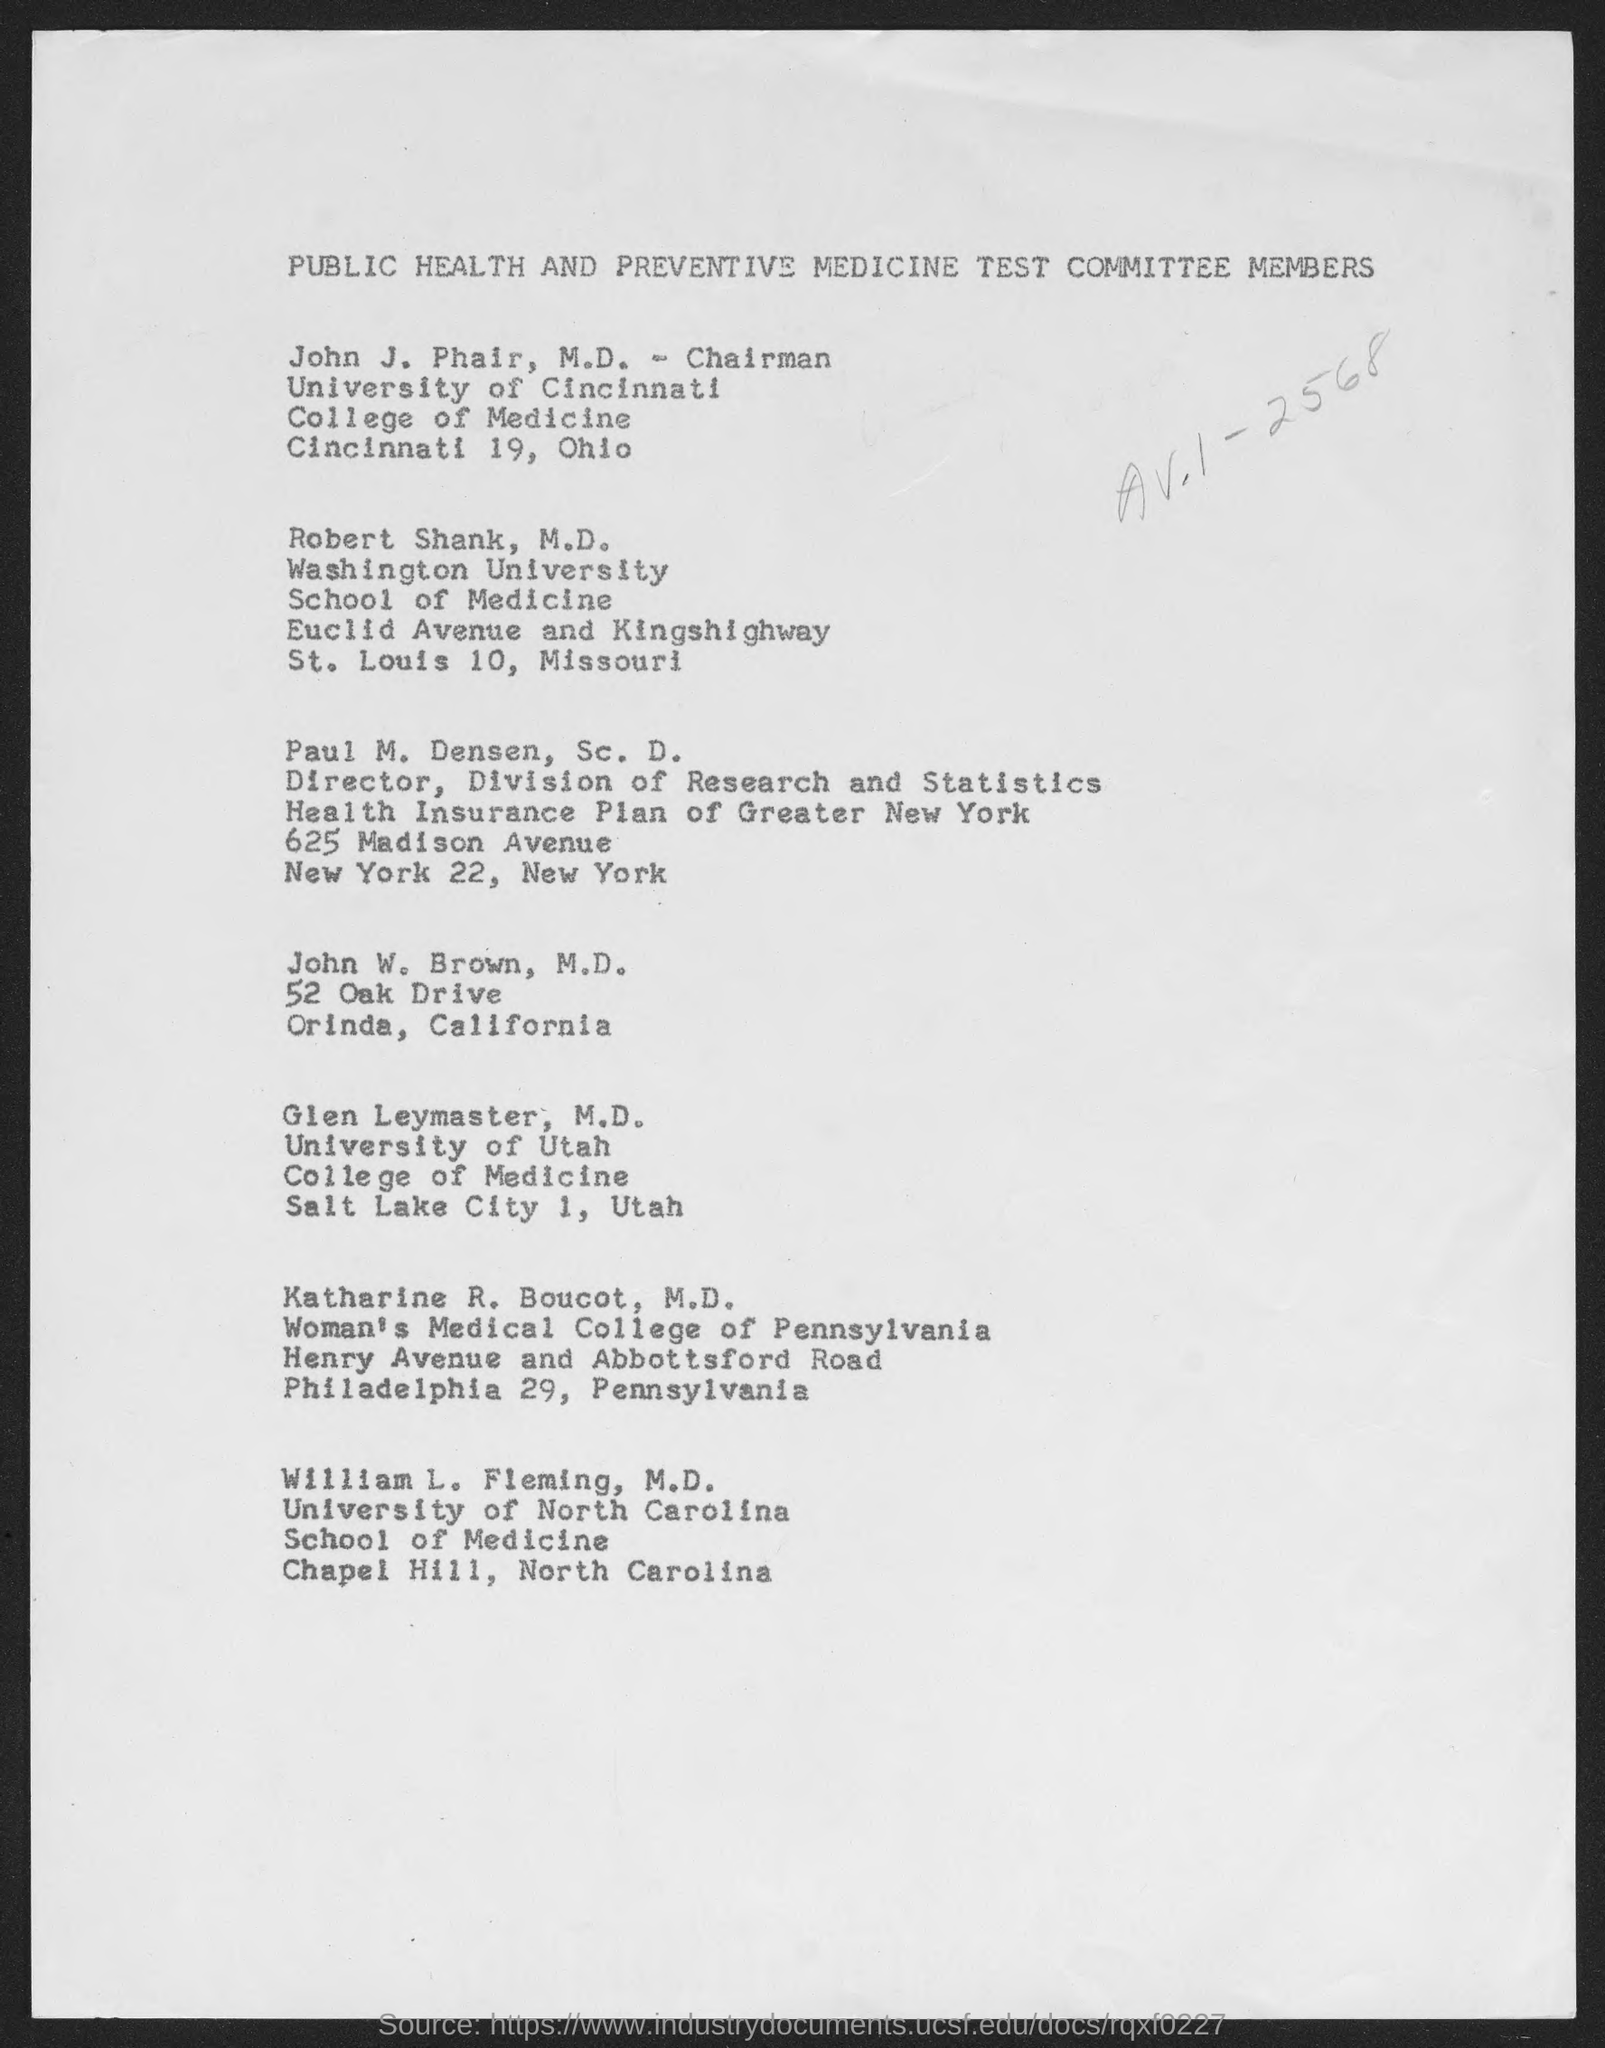Indicate a few pertinent items in this graphic. Paul M. Densen, Sc. D., is the designation of a person who holds the title of Director. Robert Shank, M.D., works at Washington University. 